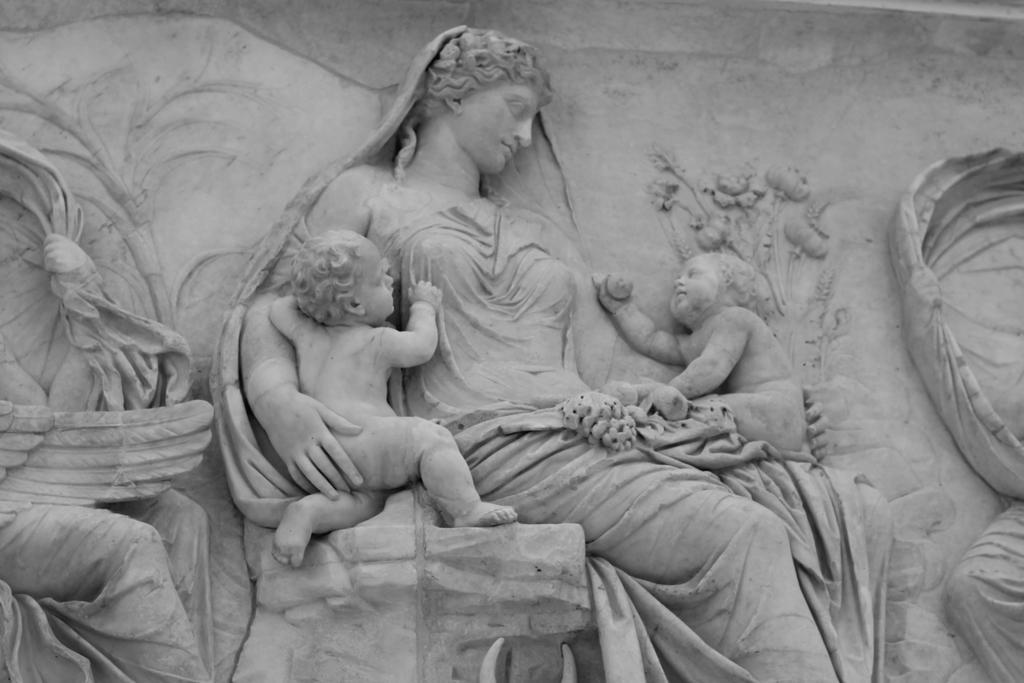How would you summarize this image in a sentence or two? In this image we can see the sculpture. 